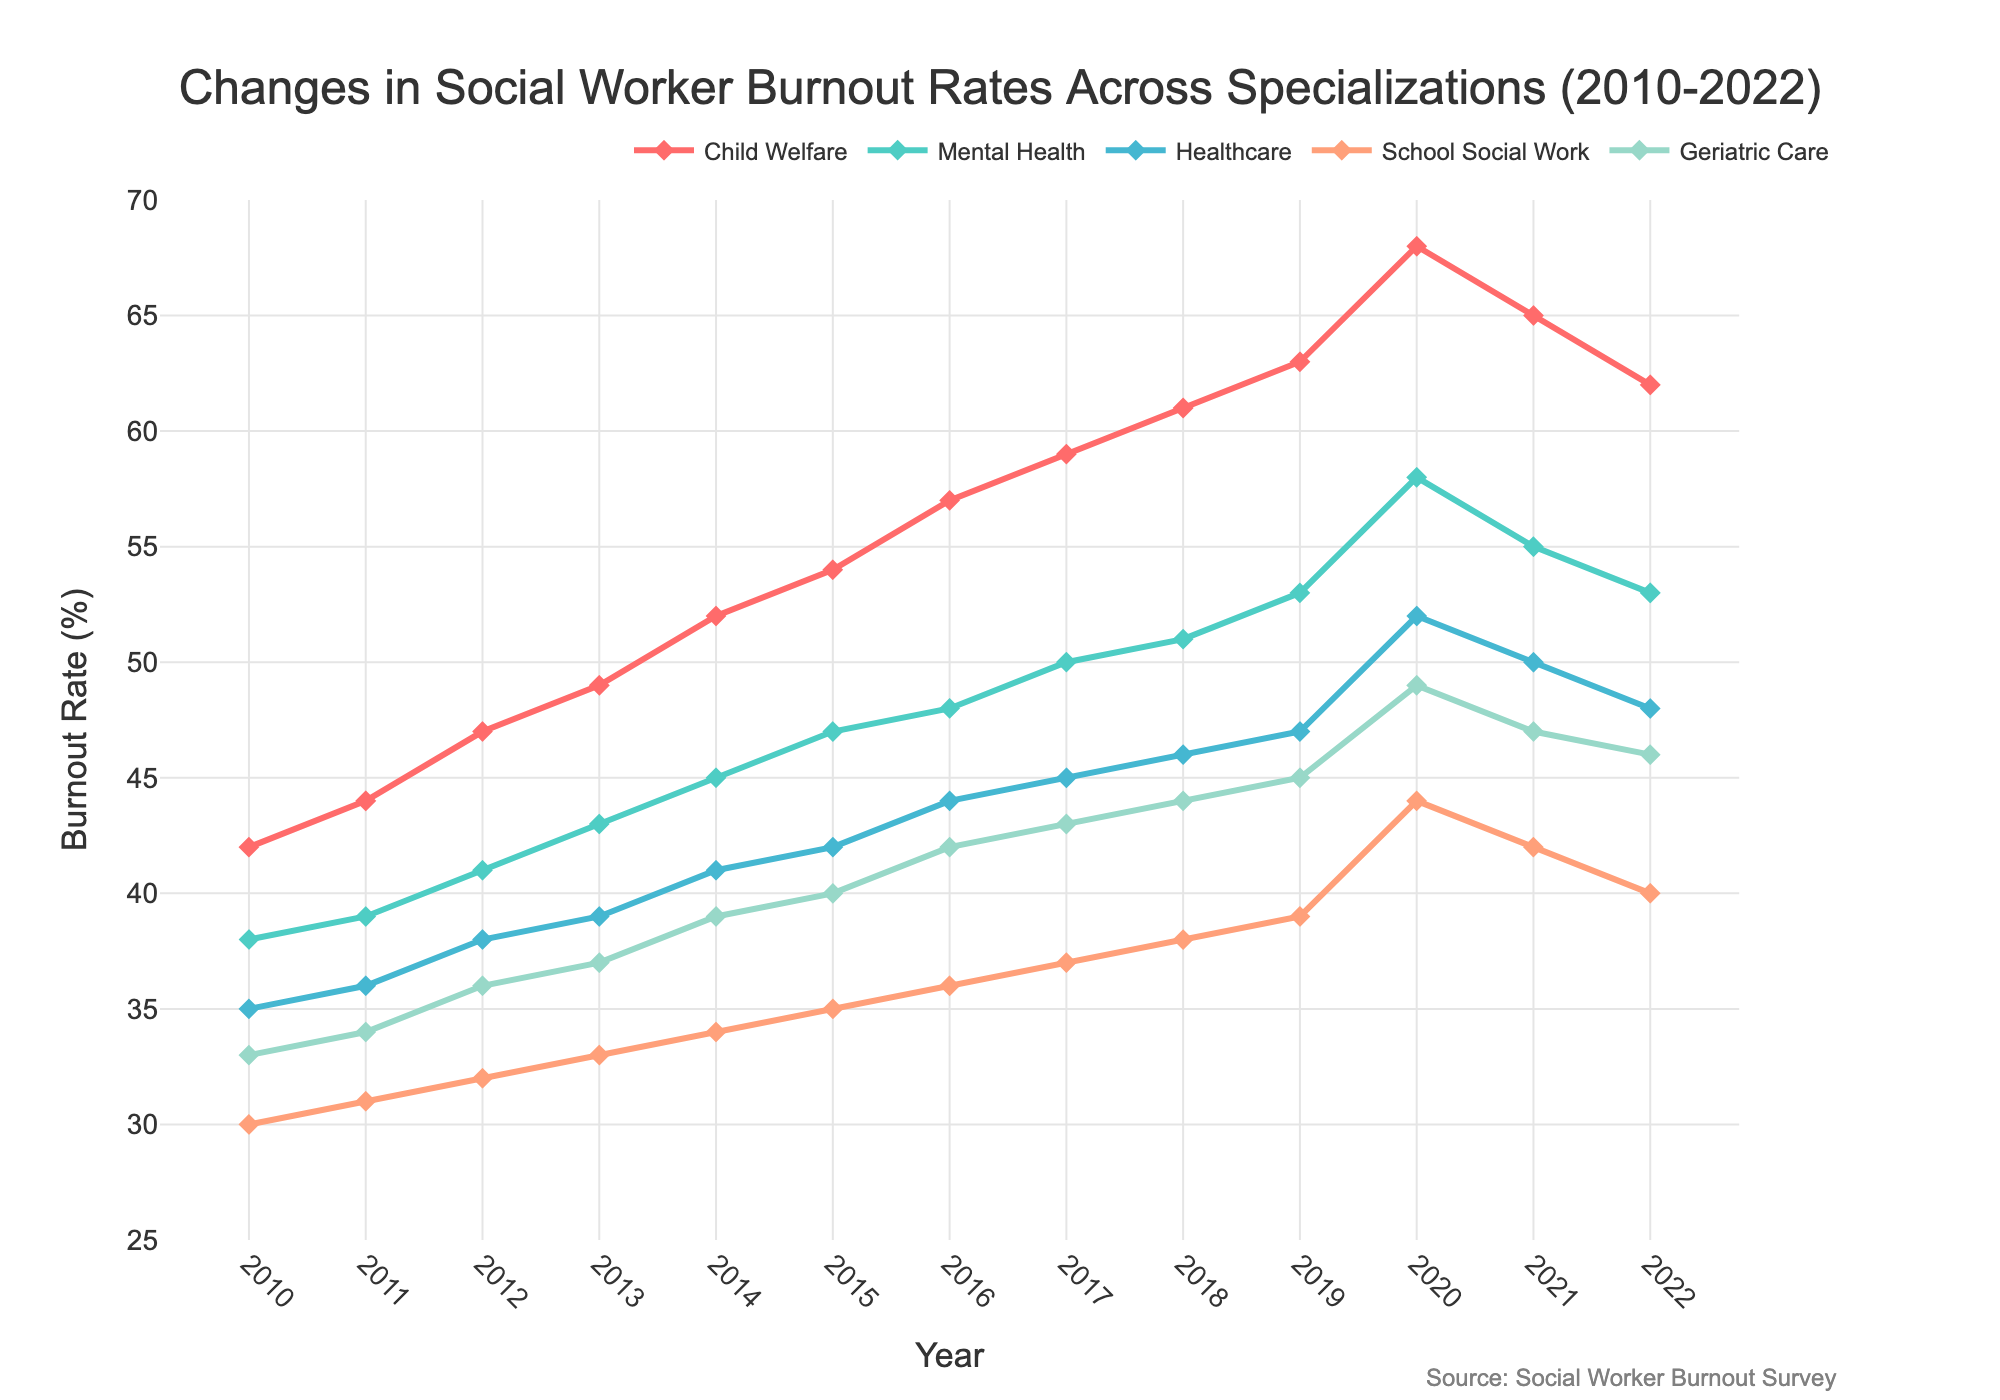What is the burnout rate for Child Welfare in 2015? Find the point on the Child Welfare line that correlates with the year 2015. The value is indicated as 54%
Answer: 54% Compare the burnout rates of Mental Health and School Social Work in 2018. Which specialization had a higher rate? Observe the y-values for Mental Health and School Social Work in 2018. Mental Health is 51% and School Social Work is 38%. Hence, Mental Health had a higher rate.
Answer: Mental Health What is the average burnout rate of Geriatric Care from 2010 to 2022? Determine the burnout rates of Geriatric Care over the years and calculate their average: (33 + 34 + 36 + 37 + 39 + 40 + 42 + 43 + 44 + 45 + 49 + 47 + 46)/13 = 41.23
Answer: 41.23 Across all specializations, which year shows the peak burnout rate? Identify the highest point for each line and observe the corresponding year. The peak rate for most lines occurs in 2020.
Answer: 2020 Which specialization showed the most significant increase in burnout rate from 2010 to 2022? Calculate the difference in rates for each specialization between 2022 and 2010: Child Welfare: (62 - 42) = 20, Mental Health: (53 - 38) = 15, Healthcare: (48 - 35) = 13, School Social Work: (40 - 30) = 10, Geriatric Care: (46 - 33) = 13. Child Welfare has the highest increase.
Answer: Child Welfare What was the burnout rate for Healthcare in 2021 and how does it compare to Geriatric Care in the same year? Identify the y-values for Healthcare and Geriatric Care in 2021. Healthcare is 50% and Geriatric Care is 47%. Healthcare's rate is higher by 3%.
Answer: Healthcare is higher by 3% Which specialization had the lowest burnout rate in 2013? Compare the y-values for each specialization in 2013. School Social Work has the lowest burnout rate at 33%.
Answer: School Social Work What is the trend in burnout rates for Child Welfare from 2018 to 2022? Observe the Child Welfare line from 2018 to 2022. The burnout rate decreased from 61% (2018) to 62% (2022). It's a decreasing trend.
Answer: Decreasing Calculate the average burnout rate for Mental Health from 2010 to 2022. Calculate the values for Mental Health over the years and determine their average: (38 + 39 + 41 + 43 + 45 + 47 + 48 + 50 + 51 + 53 + 58 + 55 + 53)/13 = 46.15
Answer: 46.15 